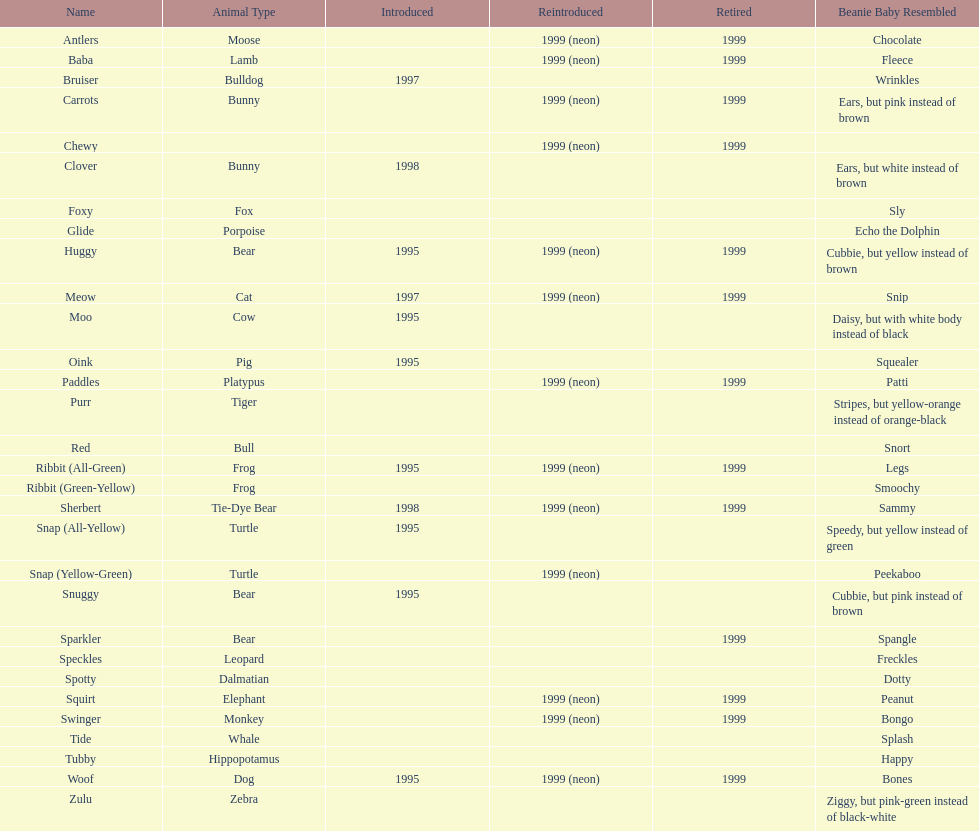Which animal type has the most pillow pals? Bear. I'm looking to parse the entire table for insights. Could you assist me with that? {'header': ['Name', 'Animal Type', 'Introduced', 'Reintroduced', 'Retired', 'Beanie Baby Resembled'], 'rows': [['Antlers', 'Moose', '', '1999 (neon)', '1999', 'Chocolate'], ['Baba', 'Lamb', '', '1999 (neon)', '1999', 'Fleece'], ['Bruiser', 'Bulldog', '1997', '', '', 'Wrinkles'], ['Carrots', 'Bunny', '', '1999 (neon)', '1999', 'Ears, but pink instead of brown'], ['Chewy', '', '', '1999 (neon)', '1999', ''], ['Clover', 'Bunny', '1998', '', '', 'Ears, but white instead of brown'], ['Foxy', 'Fox', '', '', '', 'Sly'], ['Glide', 'Porpoise', '', '', '', 'Echo the Dolphin'], ['Huggy', 'Bear', '1995', '1999 (neon)', '1999', 'Cubbie, but yellow instead of brown'], ['Meow', 'Cat', '1997', '1999 (neon)', '1999', 'Snip'], ['Moo', 'Cow', '1995', '', '', 'Daisy, but with white body instead of black'], ['Oink', 'Pig', '1995', '', '', 'Squealer'], ['Paddles', 'Platypus', '', '1999 (neon)', '1999', 'Patti'], ['Purr', 'Tiger', '', '', '', 'Stripes, but yellow-orange instead of orange-black'], ['Red', 'Bull', '', '', '', 'Snort'], ['Ribbit (All-Green)', 'Frog', '1995', '1999 (neon)', '1999', 'Legs'], ['Ribbit (Green-Yellow)', 'Frog', '', '', '', 'Smoochy'], ['Sherbert', 'Tie-Dye Bear', '1998', '1999 (neon)', '1999', 'Sammy'], ['Snap (All-Yellow)', 'Turtle', '1995', '', '', 'Speedy, but yellow instead of green'], ['Snap (Yellow-Green)', 'Turtle', '', '1999 (neon)', '', 'Peekaboo'], ['Snuggy', 'Bear', '1995', '', '', 'Cubbie, but pink instead of brown'], ['Sparkler', 'Bear', '', '', '1999', 'Spangle'], ['Speckles', 'Leopard', '', '', '', 'Freckles'], ['Spotty', 'Dalmatian', '', '', '', 'Dotty'], ['Squirt', 'Elephant', '', '1999 (neon)', '1999', 'Peanut'], ['Swinger', 'Monkey', '', '1999 (neon)', '1999', 'Bongo'], ['Tide', 'Whale', '', '', '', 'Splash'], ['Tubby', 'Hippopotamus', '', '', '', 'Happy'], ['Woof', 'Dog', '1995', '1999 (neon)', '1999', 'Bones'], ['Zulu', 'Zebra', '', '', '', 'Ziggy, but pink-green instead of black-white']]} 